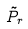<formula> <loc_0><loc_0><loc_500><loc_500>\tilde { P } _ { r }</formula> 